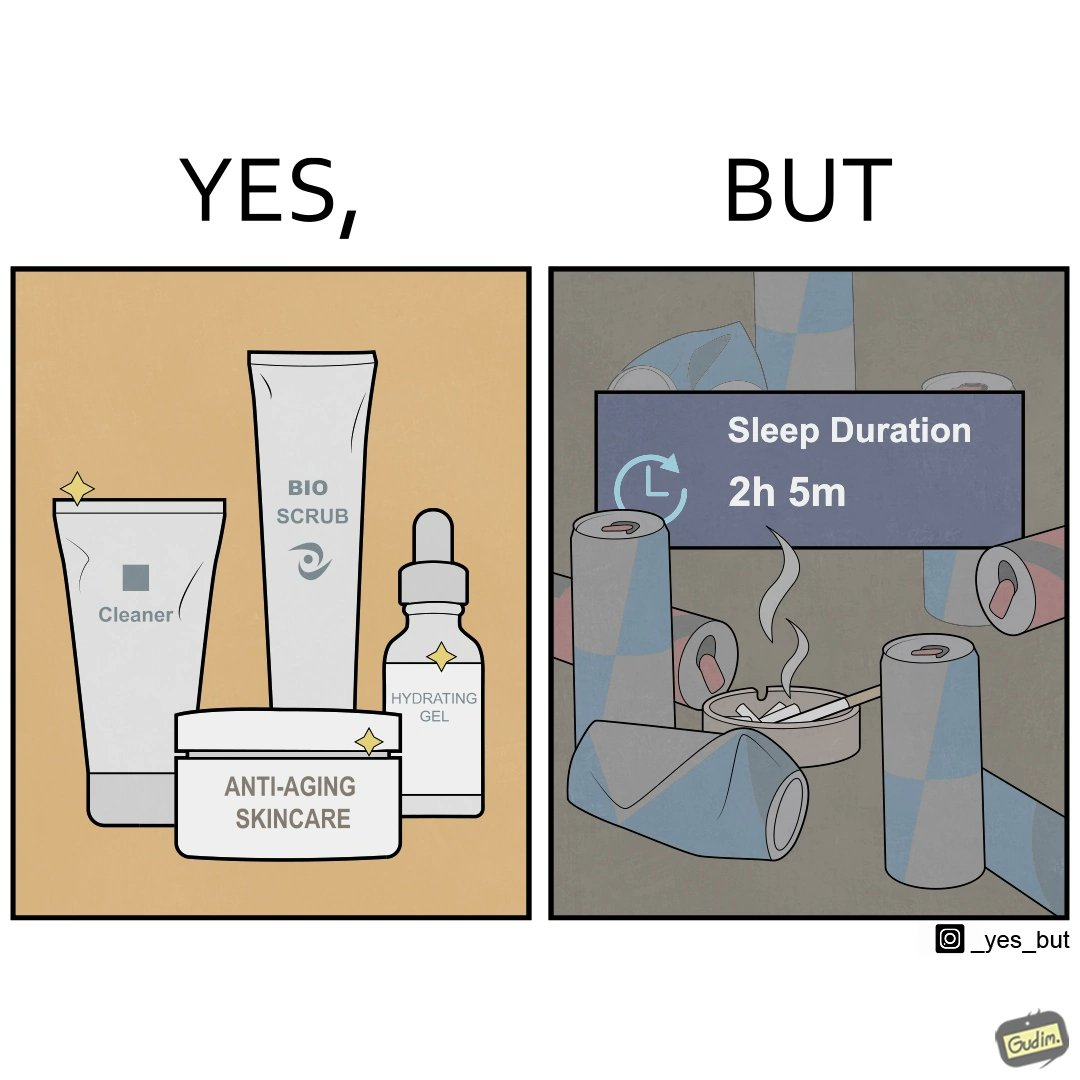Describe what you see in the left and right parts of this image. In the left part of the image: 4 Skincare products, arranged aesthetically. A tube labeled "Cleaner". A tube labeled "BIO SCRUB". A dropper bottle labeled "HYDRATING GEL". A jar called "ANTI-AGING SKINCARE". In the right part of the image: 9 cans of red bull, some standing upright, some crushed. Cans have blue and red colors. An ashtray with many cigarette butts in it and has smoke coming out. A banner that says "Sleep duration 2h 5min". 